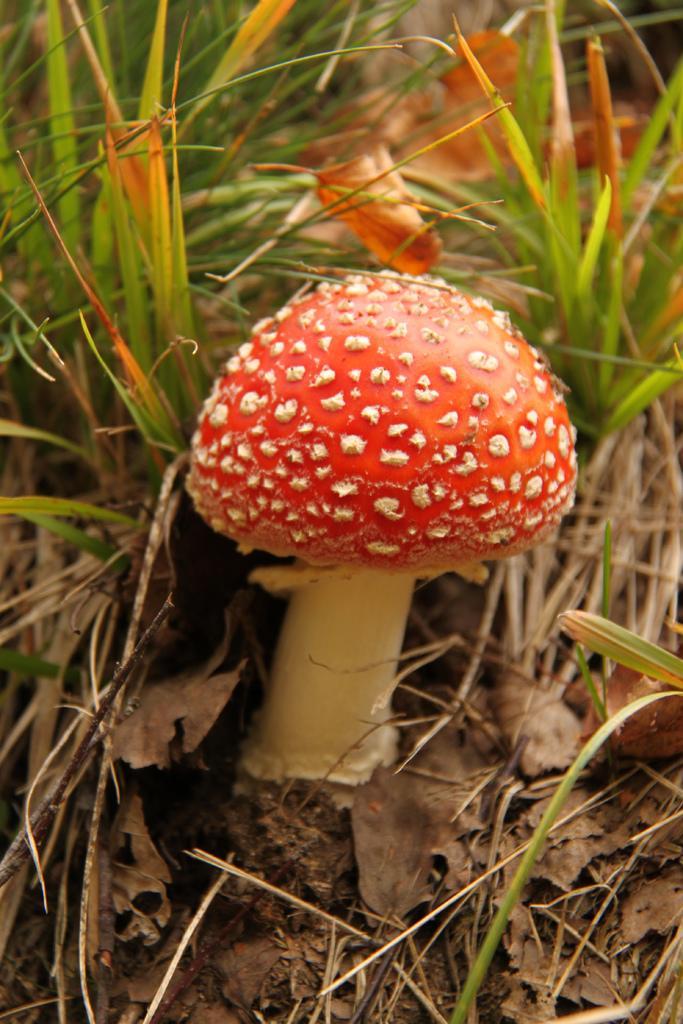Describe this image in one or two sentences. In this picture we can see a mushroom. Behind the mushroom there are dried leaves and grass. 